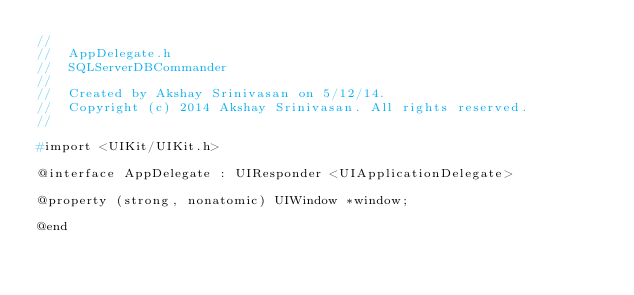<code> <loc_0><loc_0><loc_500><loc_500><_C_>//
//  AppDelegate.h
//  SQLServerDBCommander
//
//  Created by Akshay Srinivasan on 5/12/14.
//  Copyright (c) 2014 Akshay Srinivasan. All rights reserved.
//

#import <UIKit/UIKit.h>

@interface AppDelegate : UIResponder <UIApplicationDelegate>

@property (strong, nonatomic) UIWindow *window;

@end
</code> 